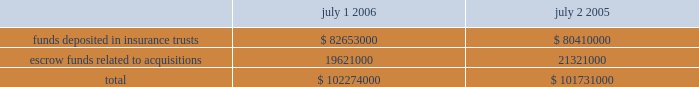Restricted cash sysco is required by its insurers to collateralize a part of the self-insured portion of its workers 2019 compensation and liability claims .
Sysco has chosen to satisfy these collateral requirements by depositing funds in insurance trusts or by issuing letters of credit .
In addition , for certain acquisitions , sysco has placed funds into escrow to be disbursed to the sellers in the event that specified operating results are attained or contingencies are resolved .
Escrowed funds related to certain acquisitions in the amount of $ 1700000 were released during fiscal 2006 , which included $ 800000 that was disbursed to sellers .
A summary of restricted cash balances appears below: .
Funds deposited in insurance trusts************************************** $ 82653000 $ 80410000 escrow funds related to acquisitions ************************************* 19621000 21321000 total************************************************************* $ 102274000 $ 101731000 7 .
Derivative financial instruments sysco manages its debt portfolio by targeting an overall desired position of fixed and floating rates and may employ interest rate swaps from time to time to achieve this goal .
The company does not use derivative financial instruments for trading or speculative purposes .
During fiscal years 2003 , 2004 and 2005 , the company entered into various interest rate swap agreements designated as fair value hedges of the related debt .
The terms of these swap agreements and the hedged items were such that the hedges were considered perfectly effective against changes in the fair value of the debt due to changes in the benchmark interest rates over their terms .
As a result , the shortcut method provided by sfas no .
133 , 2018 2018accounting for derivative instruments and hedging activities , 2019 2019 was applied and there was no need to periodically reassess the effectiveness of the hedges during the terms of the swaps .
Interest expense on the debt was adjusted to include payments made or received under the hedge agreements .
The fair value of the swaps was carried as an asset or a liability on the consolidated balance sheet and the carrying value of the hedged debt was adjusted accordingly .
There were no fair value hedges outstanding as of july 1 , 2006 or july 2 , 2005 .
The amount received upon termination of fair value hedge swap agreements was $ 5316000 and $ 1305000 in fiscal years 2005 and 2004 , respectively .
There were no terminations of fair value hedge swap agreements in fiscal 2006 .
The amount received upon termination of swap agreements is reflected as an increase in the carrying value of the related debt to reflect its fair value at termination .
This increase in the carrying value of the debt is amortized as a reduction of interest expense over the remaining term of the debt .
In march 2005 , sysco entered into a forward-starting interest rate swap with a notional amount of $ 350000000 .
In accordance with sfas no .
133 , the company designated this derivative as a cash flow hedge of the variability in the cash outflows of interest payments on $ 350000000 of the september 2005 forecasted debt issuance due to changes in the benchmark interest rate .
The fair value of the swap as of july 2 , 2005 was ( $ 32584000 ) , which is reflected in accrued expenses on the consolidated balance sheet , with the corresponding amount reflected as a loss , net of tax , in other comprehensive income ( loss ) .
In september 2005 , in conjunction with the issuance of the 5.375% ( 5.375 % ) senior notes , sysco settled the $ 350000000 notional amount forward-starting interest rate swap .
Upon settlement , sysco paid cash of $ 21196000 , which represented the fair value of the swap agreement at the time of settlement .
This amount is being amortized as interest expense over the 30-year term of the debt , and the unamortized balance is reflected as a loss , net of tax , in other comprehensive income ( loss ) .
In the normal course of business , sysco enters into forward purchase agreements for the procurement of fuel , electricity and product commodities related to sysco 2019s business .
Certain of these agreements meet the definition of a derivative and qualify for the normal purchase and sale exemption under relevant accounting literature .
The company has elected to use this exemption for these agreements and thus they are not recorded at fair value .
%%transmsg*** transmitting job : h39408 pcn : 046000000 *** %%pcmsg|44 |00010|yes|no|09/06/2006 17:22|0|1|page is valid , no graphics -- color : n| .
What percentage of restricted cash as of july 2 , 2005 was in funds deposited in insurance trusts? 
Computations: (80410000 / 101731000)
Answer: 0.79042. 